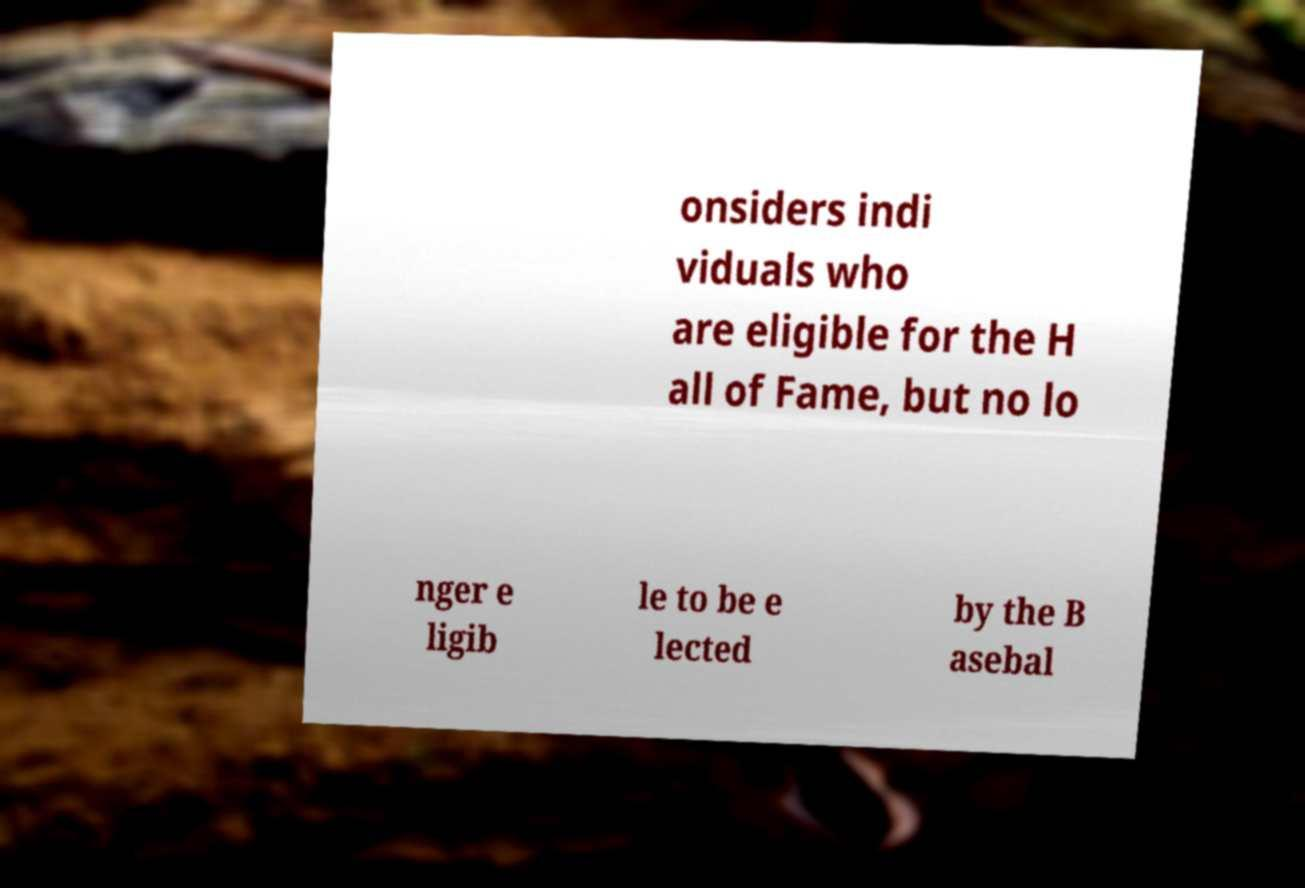There's text embedded in this image that I need extracted. Can you transcribe it verbatim? onsiders indi viduals who are eligible for the H all of Fame, but no lo nger e ligib le to be e lected by the B asebal 